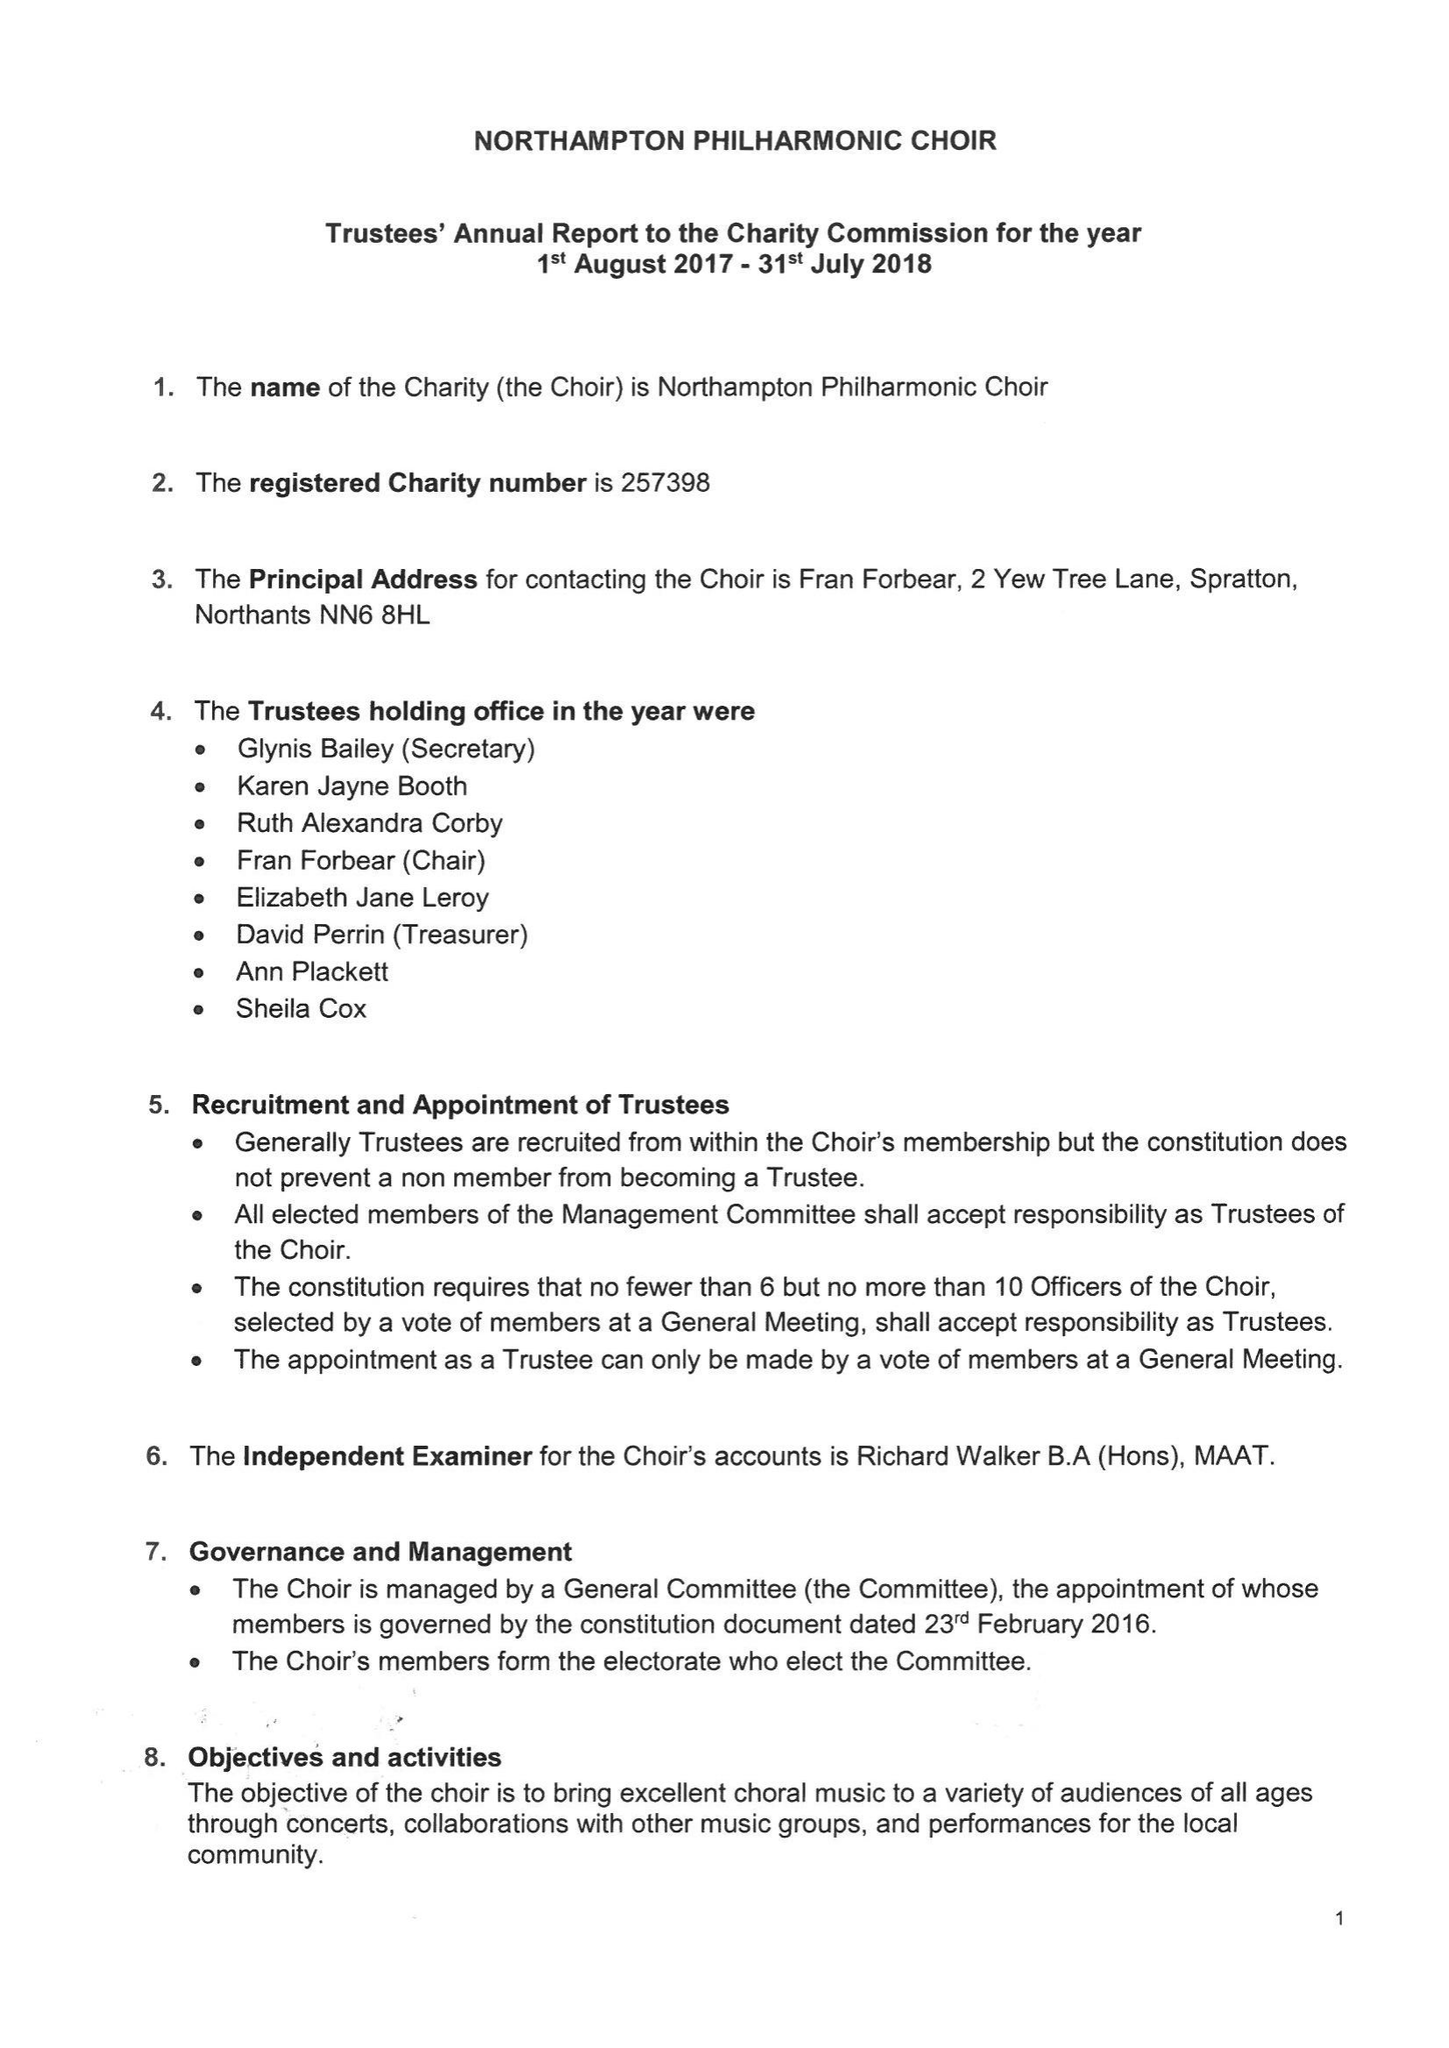What is the value for the address__postcode?
Answer the question using a single word or phrase. NN6 8HL 